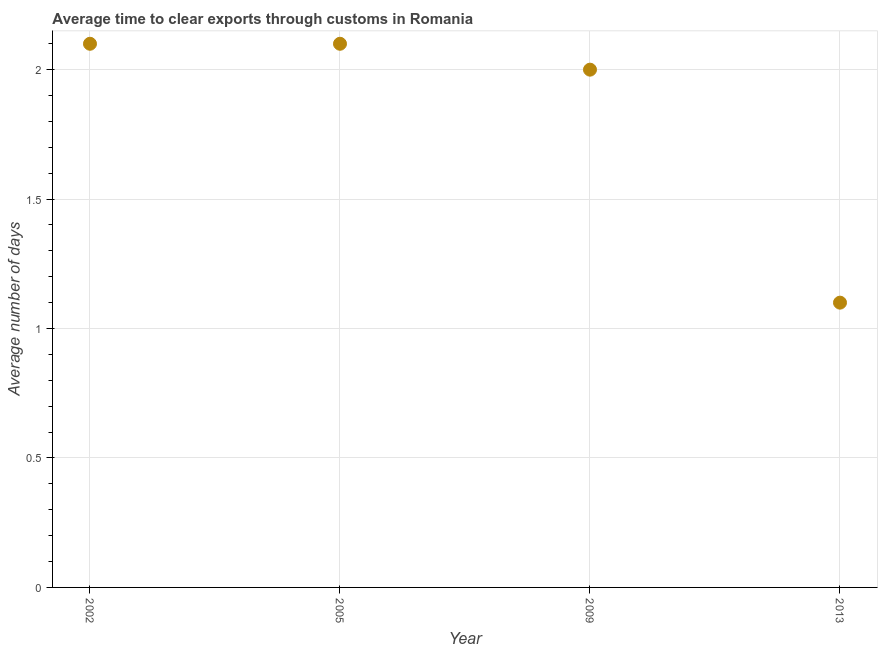Across all years, what is the minimum time to clear exports through customs?
Give a very brief answer. 1.1. In which year was the time to clear exports through customs minimum?
Keep it short and to the point. 2013. What is the sum of the time to clear exports through customs?
Offer a very short reply. 7.3. What is the average time to clear exports through customs per year?
Offer a very short reply. 1.83. What is the median time to clear exports through customs?
Ensure brevity in your answer.  2.05. What is the ratio of the time to clear exports through customs in 2009 to that in 2013?
Provide a short and direct response. 1.82. Is the time to clear exports through customs in 2005 less than that in 2013?
Make the answer very short. No. Is the difference between the time to clear exports through customs in 2009 and 2013 greater than the difference between any two years?
Provide a short and direct response. No. Is the sum of the time to clear exports through customs in 2002 and 2013 greater than the maximum time to clear exports through customs across all years?
Your answer should be very brief. Yes. In how many years, is the time to clear exports through customs greater than the average time to clear exports through customs taken over all years?
Offer a terse response. 3. What is the difference between two consecutive major ticks on the Y-axis?
Provide a succinct answer. 0.5. Are the values on the major ticks of Y-axis written in scientific E-notation?
Provide a short and direct response. No. What is the title of the graph?
Ensure brevity in your answer.  Average time to clear exports through customs in Romania. What is the label or title of the Y-axis?
Make the answer very short. Average number of days. What is the Average number of days in 2005?
Offer a very short reply. 2.1. What is the Average number of days in 2013?
Keep it short and to the point. 1.1. What is the difference between the Average number of days in 2002 and 2009?
Make the answer very short. 0.1. What is the difference between the Average number of days in 2002 and 2013?
Your response must be concise. 1. What is the difference between the Average number of days in 2009 and 2013?
Your answer should be compact. 0.9. What is the ratio of the Average number of days in 2002 to that in 2013?
Keep it short and to the point. 1.91. What is the ratio of the Average number of days in 2005 to that in 2013?
Give a very brief answer. 1.91. What is the ratio of the Average number of days in 2009 to that in 2013?
Provide a short and direct response. 1.82. 